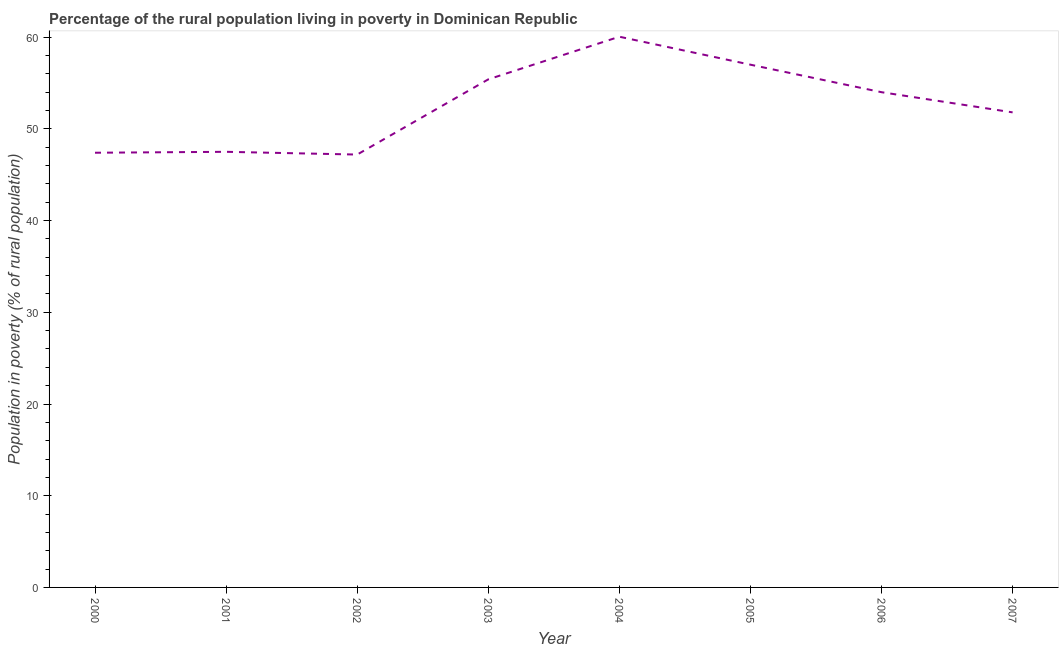What is the percentage of rural population living below poverty line in 2003?
Offer a very short reply. 55.4. Across all years, what is the maximum percentage of rural population living below poverty line?
Your response must be concise. 60.05. Across all years, what is the minimum percentage of rural population living below poverty line?
Keep it short and to the point. 47.2. In which year was the percentage of rural population living below poverty line maximum?
Ensure brevity in your answer.  2004. What is the sum of the percentage of rural population living below poverty line?
Your answer should be compact. 420.35. What is the difference between the percentage of rural population living below poverty line in 2006 and 2007?
Provide a short and direct response. 2.2. What is the average percentage of rural population living below poverty line per year?
Ensure brevity in your answer.  52.54. What is the median percentage of rural population living below poverty line?
Offer a terse response. 52.9. Do a majority of the years between 2006 and 2005 (inclusive) have percentage of rural population living below poverty line greater than 22 %?
Offer a very short reply. No. What is the ratio of the percentage of rural population living below poverty line in 2002 to that in 2007?
Give a very brief answer. 0.91. Is the percentage of rural population living below poverty line in 2006 less than that in 2007?
Provide a short and direct response. No. What is the difference between the highest and the second highest percentage of rural population living below poverty line?
Offer a terse response. 3.05. Is the sum of the percentage of rural population living below poverty line in 2002 and 2007 greater than the maximum percentage of rural population living below poverty line across all years?
Offer a very short reply. Yes. What is the difference between the highest and the lowest percentage of rural population living below poverty line?
Offer a terse response. 12.85. How many lines are there?
Make the answer very short. 1. How many years are there in the graph?
Your answer should be compact. 8. Are the values on the major ticks of Y-axis written in scientific E-notation?
Offer a very short reply. No. Does the graph contain any zero values?
Provide a short and direct response. No. Does the graph contain grids?
Keep it short and to the point. No. What is the title of the graph?
Ensure brevity in your answer.  Percentage of the rural population living in poverty in Dominican Republic. What is the label or title of the Y-axis?
Offer a terse response. Population in poverty (% of rural population). What is the Population in poverty (% of rural population) in 2000?
Keep it short and to the point. 47.4. What is the Population in poverty (% of rural population) in 2001?
Offer a very short reply. 47.5. What is the Population in poverty (% of rural population) in 2002?
Offer a very short reply. 47.2. What is the Population in poverty (% of rural population) of 2003?
Provide a succinct answer. 55.4. What is the Population in poverty (% of rural population) in 2004?
Provide a short and direct response. 60.05. What is the Population in poverty (% of rural population) in 2005?
Provide a short and direct response. 57. What is the Population in poverty (% of rural population) of 2006?
Your answer should be very brief. 54. What is the Population in poverty (% of rural population) of 2007?
Offer a very short reply. 51.8. What is the difference between the Population in poverty (% of rural population) in 2000 and 2001?
Give a very brief answer. -0.1. What is the difference between the Population in poverty (% of rural population) in 2000 and 2003?
Provide a succinct answer. -8. What is the difference between the Population in poverty (% of rural population) in 2000 and 2004?
Make the answer very short. -12.65. What is the difference between the Population in poverty (% of rural population) in 2000 and 2005?
Provide a short and direct response. -9.6. What is the difference between the Population in poverty (% of rural population) in 2000 and 2007?
Make the answer very short. -4.4. What is the difference between the Population in poverty (% of rural population) in 2001 and 2003?
Your answer should be very brief. -7.9. What is the difference between the Population in poverty (% of rural population) in 2001 and 2004?
Your answer should be compact. -12.55. What is the difference between the Population in poverty (% of rural population) in 2002 and 2003?
Give a very brief answer. -8.2. What is the difference between the Population in poverty (% of rural population) in 2002 and 2004?
Give a very brief answer. -12.85. What is the difference between the Population in poverty (% of rural population) in 2002 and 2006?
Your response must be concise. -6.8. What is the difference between the Population in poverty (% of rural population) in 2003 and 2004?
Your answer should be very brief. -4.65. What is the difference between the Population in poverty (% of rural population) in 2003 and 2007?
Your answer should be very brief. 3.6. What is the difference between the Population in poverty (% of rural population) in 2004 and 2005?
Offer a terse response. 3.05. What is the difference between the Population in poverty (% of rural population) in 2004 and 2006?
Your answer should be compact. 6.05. What is the difference between the Population in poverty (% of rural population) in 2004 and 2007?
Offer a very short reply. 8.25. What is the difference between the Population in poverty (% of rural population) in 2005 and 2007?
Your answer should be very brief. 5.2. What is the ratio of the Population in poverty (% of rural population) in 2000 to that in 2003?
Offer a very short reply. 0.86. What is the ratio of the Population in poverty (% of rural population) in 2000 to that in 2004?
Make the answer very short. 0.79. What is the ratio of the Population in poverty (% of rural population) in 2000 to that in 2005?
Ensure brevity in your answer.  0.83. What is the ratio of the Population in poverty (% of rural population) in 2000 to that in 2006?
Make the answer very short. 0.88. What is the ratio of the Population in poverty (% of rural population) in 2000 to that in 2007?
Keep it short and to the point. 0.92. What is the ratio of the Population in poverty (% of rural population) in 2001 to that in 2003?
Your answer should be very brief. 0.86. What is the ratio of the Population in poverty (% of rural population) in 2001 to that in 2004?
Provide a succinct answer. 0.79. What is the ratio of the Population in poverty (% of rural population) in 2001 to that in 2005?
Make the answer very short. 0.83. What is the ratio of the Population in poverty (% of rural population) in 2001 to that in 2006?
Provide a succinct answer. 0.88. What is the ratio of the Population in poverty (% of rural population) in 2001 to that in 2007?
Provide a succinct answer. 0.92. What is the ratio of the Population in poverty (% of rural population) in 2002 to that in 2003?
Give a very brief answer. 0.85. What is the ratio of the Population in poverty (% of rural population) in 2002 to that in 2004?
Your response must be concise. 0.79. What is the ratio of the Population in poverty (% of rural population) in 2002 to that in 2005?
Ensure brevity in your answer.  0.83. What is the ratio of the Population in poverty (% of rural population) in 2002 to that in 2006?
Provide a succinct answer. 0.87. What is the ratio of the Population in poverty (% of rural population) in 2002 to that in 2007?
Provide a short and direct response. 0.91. What is the ratio of the Population in poverty (% of rural population) in 2003 to that in 2004?
Make the answer very short. 0.92. What is the ratio of the Population in poverty (% of rural population) in 2003 to that in 2005?
Your answer should be very brief. 0.97. What is the ratio of the Population in poverty (% of rural population) in 2003 to that in 2007?
Give a very brief answer. 1.07. What is the ratio of the Population in poverty (% of rural population) in 2004 to that in 2005?
Your answer should be compact. 1.05. What is the ratio of the Population in poverty (% of rural population) in 2004 to that in 2006?
Your answer should be compact. 1.11. What is the ratio of the Population in poverty (% of rural population) in 2004 to that in 2007?
Ensure brevity in your answer.  1.16. What is the ratio of the Population in poverty (% of rural population) in 2005 to that in 2006?
Your answer should be compact. 1.06. What is the ratio of the Population in poverty (% of rural population) in 2005 to that in 2007?
Your answer should be compact. 1.1. What is the ratio of the Population in poverty (% of rural population) in 2006 to that in 2007?
Ensure brevity in your answer.  1.04. 